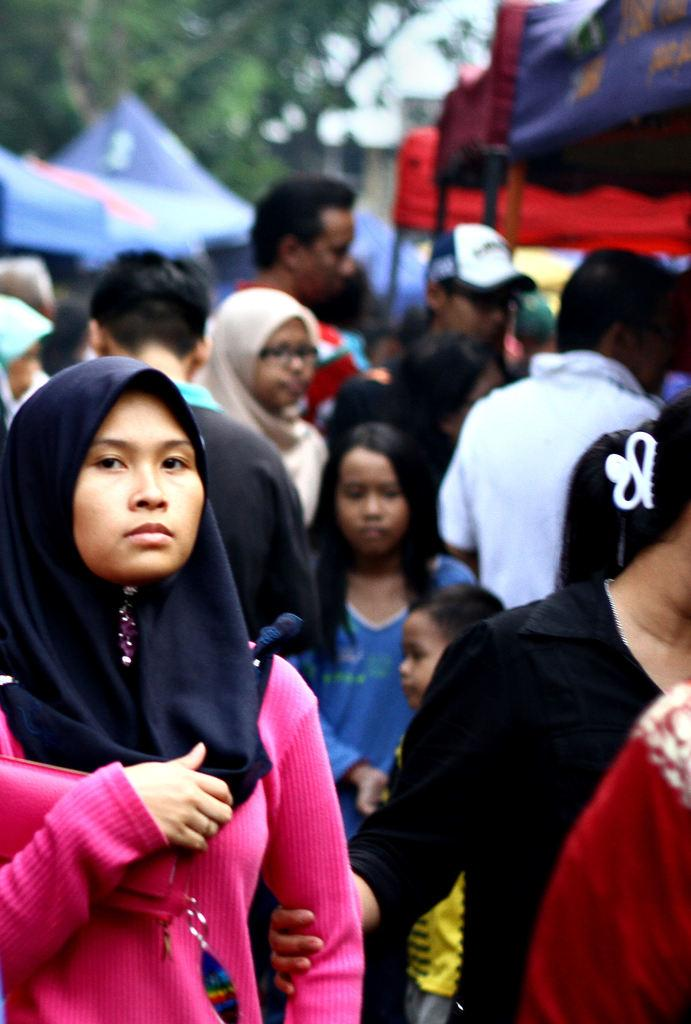What are the people in the image doing? The people in the image are standing and walking in the street. What else can be seen in the image besides people? There are stalls in the image. Can you describe the background of the image? The background of the image is blurred. What rate of memory usage is displayed on the shelf in the image? There is no shelf or memory usage information present in the image. 